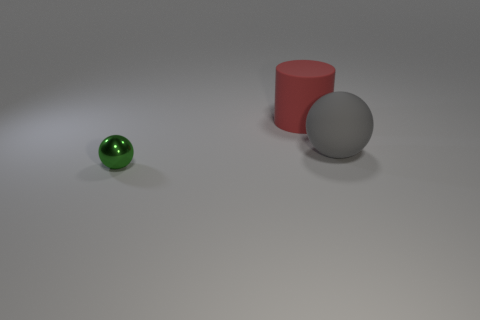What do the sizes of the objects in the image suggest about their possible use or function? Given their varied sizes, the objects could be used for teaching or demonstration purposes, illustrating concepts such as geometry, spatial relationships, or the physics of light and reflection. For example, the small green sphere could represent a particle in a physics demonstration, while the larger objects might be used to show principles of scale or volume. 